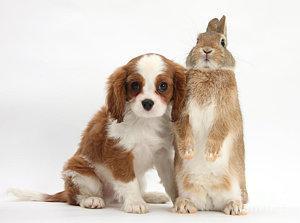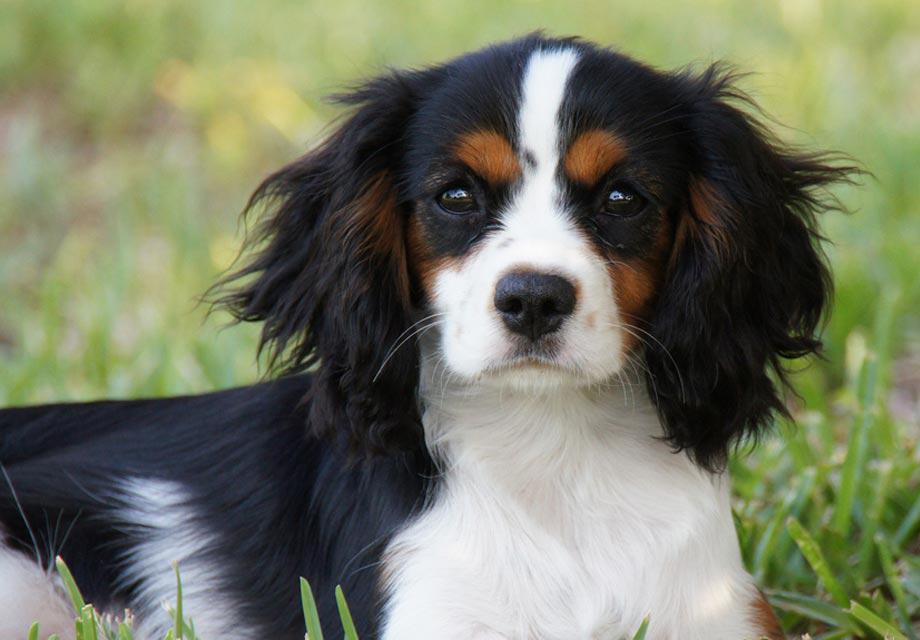The first image is the image on the left, the second image is the image on the right. Considering the images on both sides, is "There are exactly two animals in the image on the left." valid? Answer yes or no. Yes. 